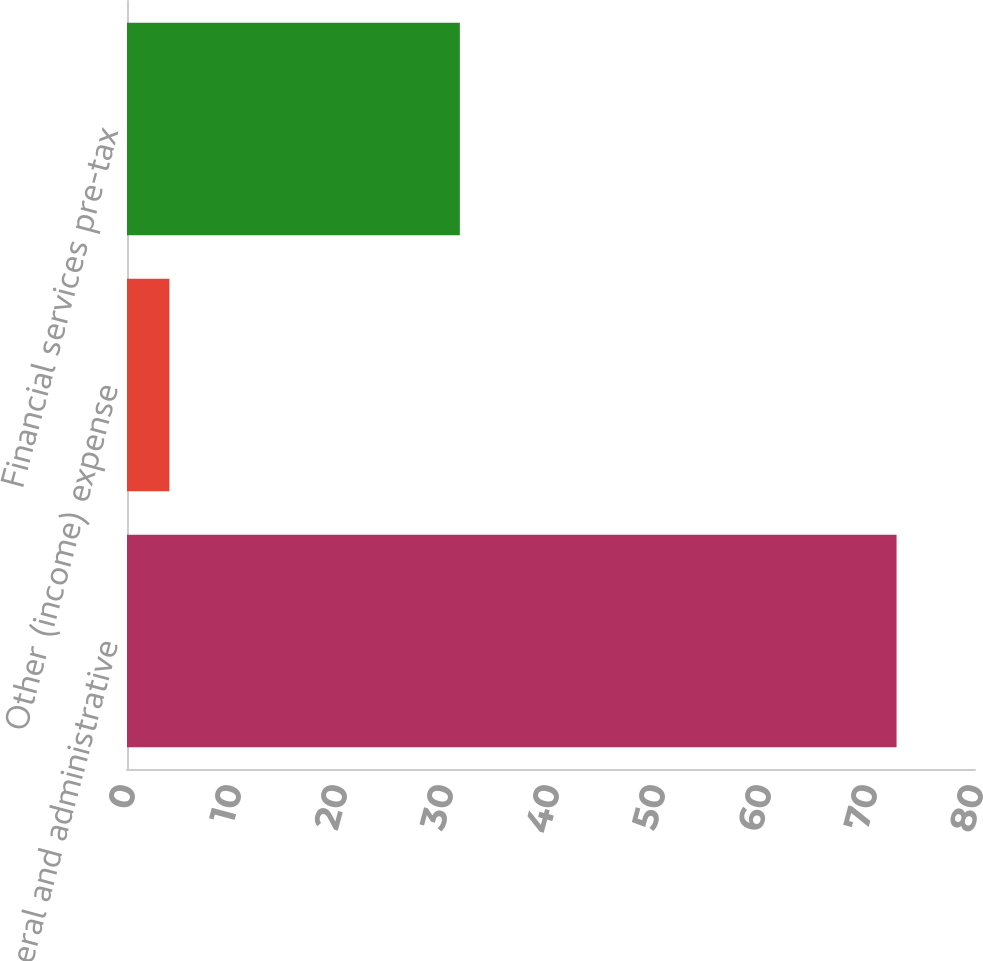Convert chart to OTSL. <chart><loc_0><loc_0><loc_500><loc_500><bar_chart><fcel>General and administrative<fcel>Other (income) expense<fcel>Financial services pre-tax<nl><fcel>72.6<fcel>4<fcel>31.4<nl></chart> 